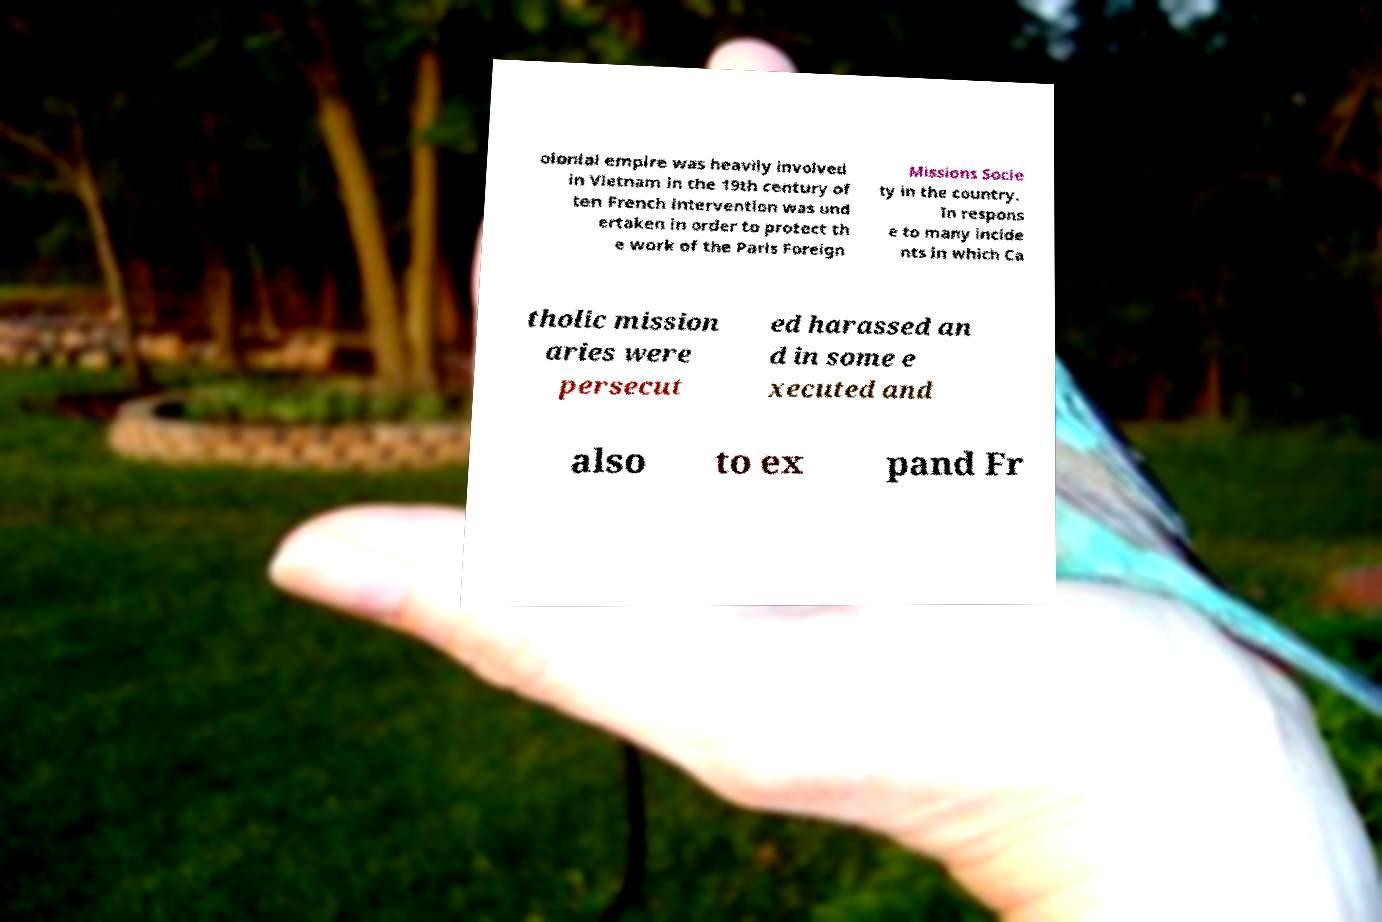Could you assist in decoding the text presented in this image and type it out clearly? olonial empire was heavily involved in Vietnam in the 19th century of ten French intervention was und ertaken in order to protect th e work of the Paris Foreign Missions Socie ty in the country. In respons e to many incide nts in which Ca tholic mission aries were persecut ed harassed an d in some e xecuted and also to ex pand Fr 